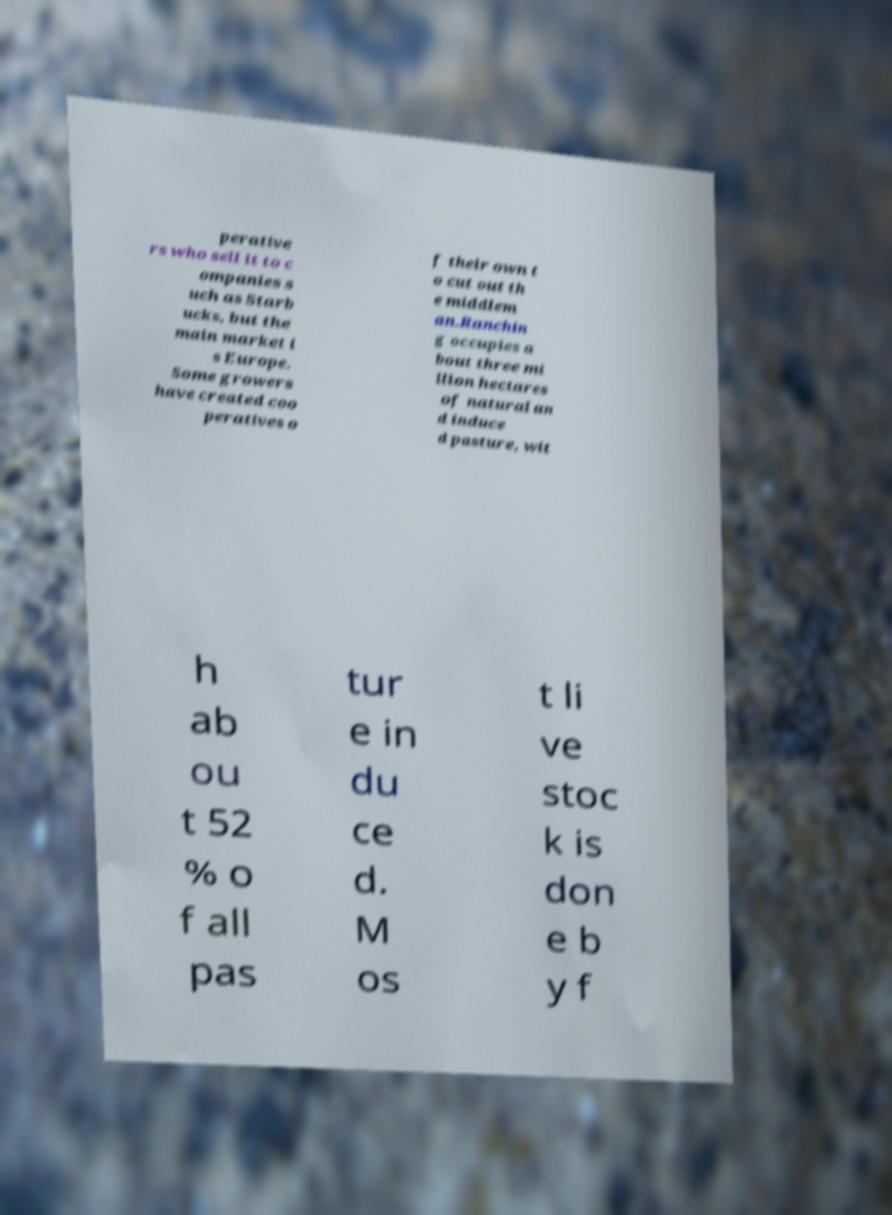I need the written content from this picture converted into text. Can you do that? perative rs who sell it to c ompanies s uch as Starb ucks, but the main market i s Europe. Some growers have created coo peratives o f their own t o cut out th e middlem an.Ranchin g occupies a bout three mi llion hectares of natural an d induce d pasture, wit h ab ou t 52 % o f all pas tur e in du ce d. M os t li ve stoc k is don e b y f 